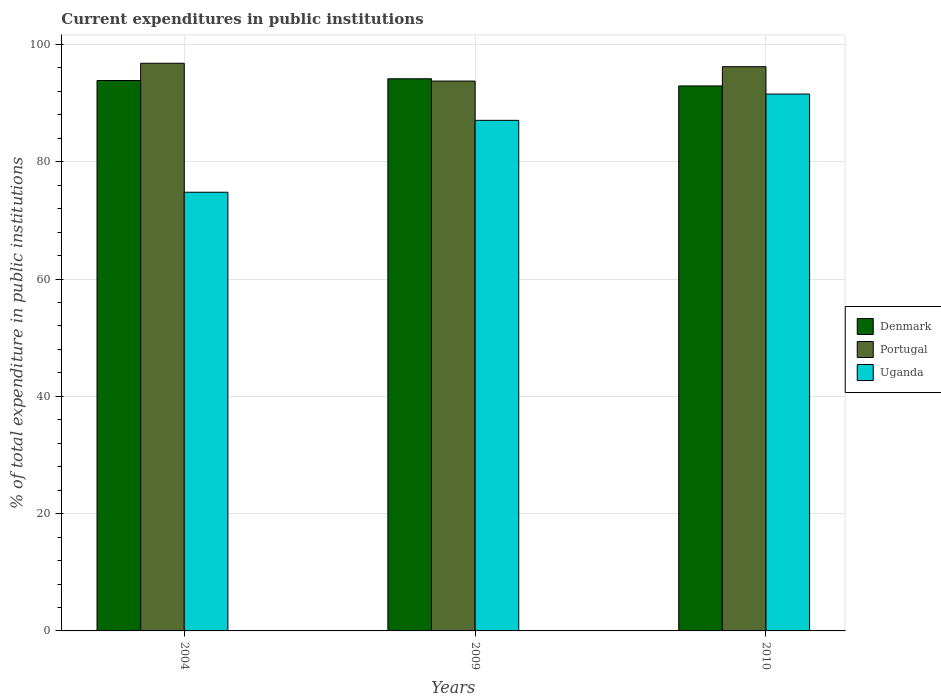How many different coloured bars are there?
Give a very brief answer. 3. How many groups of bars are there?
Your answer should be compact. 3. How many bars are there on the 2nd tick from the right?
Give a very brief answer. 3. What is the current expenditures in public institutions in Portugal in 2004?
Provide a short and direct response. 96.79. Across all years, what is the maximum current expenditures in public institutions in Portugal?
Give a very brief answer. 96.79. Across all years, what is the minimum current expenditures in public institutions in Uganda?
Offer a very short reply. 74.8. In which year was the current expenditures in public institutions in Portugal maximum?
Ensure brevity in your answer.  2004. In which year was the current expenditures in public institutions in Uganda minimum?
Offer a terse response. 2004. What is the total current expenditures in public institutions in Denmark in the graph?
Offer a very short reply. 280.92. What is the difference between the current expenditures in public institutions in Denmark in 2004 and that in 2010?
Make the answer very short. 0.93. What is the difference between the current expenditures in public institutions in Denmark in 2010 and the current expenditures in public institutions in Portugal in 2009?
Your answer should be compact. -0.83. What is the average current expenditures in public institutions in Portugal per year?
Your answer should be compact. 95.59. In the year 2010, what is the difference between the current expenditures in public institutions in Portugal and current expenditures in public institutions in Uganda?
Give a very brief answer. 4.66. What is the ratio of the current expenditures in public institutions in Uganda in 2004 to that in 2010?
Make the answer very short. 0.82. Is the current expenditures in public institutions in Uganda in 2004 less than that in 2009?
Make the answer very short. Yes. Is the difference between the current expenditures in public institutions in Portugal in 2004 and 2009 greater than the difference between the current expenditures in public institutions in Uganda in 2004 and 2009?
Give a very brief answer. Yes. What is the difference between the highest and the second highest current expenditures in public institutions in Uganda?
Make the answer very short. 4.49. What is the difference between the highest and the lowest current expenditures in public institutions in Uganda?
Provide a short and direct response. 16.75. Is the sum of the current expenditures in public institutions in Portugal in 2004 and 2009 greater than the maximum current expenditures in public institutions in Denmark across all years?
Offer a very short reply. Yes. What does the 1st bar from the right in 2009 represents?
Your answer should be compact. Uganda. Is it the case that in every year, the sum of the current expenditures in public institutions in Portugal and current expenditures in public institutions in Uganda is greater than the current expenditures in public institutions in Denmark?
Provide a short and direct response. Yes. Are all the bars in the graph horizontal?
Your answer should be compact. No. How many years are there in the graph?
Provide a short and direct response. 3. What is the difference between two consecutive major ticks on the Y-axis?
Your response must be concise. 20. How many legend labels are there?
Your answer should be very brief. 3. How are the legend labels stacked?
Give a very brief answer. Vertical. What is the title of the graph?
Keep it short and to the point. Current expenditures in public institutions. What is the label or title of the X-axis?
Your answer should be compact. Years. What is the label or title of the Y-axis?
Ensure brevity in your answer.  % of total expenditure in public institutions. What is the % of total expenditure in public institutions of Denmark in 2004?
Provide a short and direct response. 93.85. What is the % of total expenditure in public institutions in Portugal in 2004?
Offer a very short reply. 96.79. What is the % of total expenditure in public institutions in Uganda in 2004?
Your answer should be compact. 74.8. What is the % of total expenditure in public institutions in Denmark in 2009?
Provide a short and direct response. 94.15. What is the % of total expenditure in public institutions of Portugal in 2009?
Offer a very short reply. 93.76. What is the % of total expenditure in public institutions in Uganda in 2009?
Keep it short and to the point. 87.06. What is the % of total expenditure in public institutions in Denmark in 2010?
Keep it short and to the point. 92.93. What is the % of total expenditure in public institutions of Portugal in 2010?
Make the answer very short. 96.21. What is the % of total expenditure in public institutions in Uganda in 2010?
Your answer should be very brief. 91.54. Across all years, what is the maximum % of total expenditure in public institutions of Denmark?
Give a very brief answer. 94.15. Across all years, what is the maximum % of total expenditure in public institutions in Portugal?
Offer a terse response. 96.79. Across all years, what is the maximum % of total expenditure in public institutions of Uganda?
Ensure brevity in your answer.  91.54. Across all years, what is the minimum % of total expenditure in public institutions in Denmark?
Your answer should be very brief. 92.93. Across all years, what is the minimum % of total expenditure in public institutions of Portugal?
Provide a short and direct response. 93.76. Across all years, what is the minimum % of total expenditure in public institutions in Uganda?
Your answer should be compact. 74.8. What is the total % of total expenditure in public institutions of Denmark in the graph?
Your answer should be very brief. 280.92. What is the total % of total expenditure in public institutions of Portugal in the graph?
Make the answer very short. 286.76. What is the total % of total expenditure in public institutions of Uganda in the graph?
Offer a very short reply. 253.4. What is the difference between the % of total expenditure in public institutions of Denmark in 2004 and that in 2009?
Provide a short and direct response. -0.29. What is the difference between the % of total expenditure in public institutions of Portugal in 2004 and that in 2009?
Provide a short and direct response. 3.04. What is the difference between the % of total expenditure in public institutions of Uganda in 2004 and that in 2009?
Your response must be concise. -12.26. What is the difference between the % of total expenditure in public institutions in Denmark in 2004 and that in 2010?
Provide a short and direct response. 0.93. What is the difference between the % of total expenditure in public institutions in Portugal in 2004 and that in 2010?
Offer a terse response. 0.58. What is the difference between the % of total expenditure in public institutions in Uganda in 2004 and that in 2010?
Ensure brevity in your answer.  -16.75. What is the difference between the % of total expenditure in public institutions of Denmark in 2009 and that in 2010?
Offer a very short reply. 1.22. What is the difference between the % of total expenditure in public institutions of Portugal in 2009 and that in 2010?
Your answer should be very brief. -2.45. What is the difference between the % of total expenditure in public institutions in Uganda in 2009 and that in 2010?
Your answer should be very brief. -4.49. What is the difference between the % of total expenditure in public institutions of Denmark in 2004 and the % of total expenditure in public institutions of Portugal in 2009?
Your response must be concise. 0.1. What is the difference between the % of total expenditure in public institutions of Denmark in 2004 and the % of total expenditure in public institutions of Uganda in 2009?
Offer a very short reply. 6.79. What is the difference between the % of total expenditure in public institutions of Portugal in 2004 and the % of total expenditure in public institutions of Uganda in 2009?
Make the answer very short. 9.73. What is the difference between the % of total expenditure in public institutions in Denmark in 2004 and the % of total expenditure in public institutions in Portugal in 2010?
Ensure brevity in your answer.  -2.36. What is the difference between the % of total expenditure in public institutions in Denmark in 2004 and the % of total expenditure in public institutions in Uganda in 2010?
Ensure brevity in your answer.  2.31. What is the difference between the % of total expenditure in public institutions in Portugal in 2004 and the % of total expenditure in public institutions in Uganda in 2010?
Offer a very short reply. 5.25. What is the difference between the % of total expenditure in public institutions of Denmark in 2009 and the % of total expenditure in public institutions of Portugal in 2010?
Offer a very short reply. -2.06. What is the difference between the % of total expenditure in public institutions in Denmark in 2009 and the % of total expenditure in public institutions in Uganda in 2010?
Make the answer very short. 2.6. What is the difference between the % of total expenditure in public institutions of Portugal in 2009 and the % of total expenditure in public institutions of Uganda in 2010?
Provide a short and direct response. 2.21. What is the average % of total expenditure in public institutions of Denmark per year?
Your answer should be compact. 93.64. What is the average % of total expenditure in public institutions in Portugal per year?
Make the answer very short. 95.59. What is the average % of total expenditure in public institutions of Uganda per year?
Your answer should be compact. 84.47. In the year 2004, what is the difference between the % of total expenditure in public institutions in Denmark and % of total expenditure in public institutions in Portugal?
Your response must be concise. -2.94. In the year 2004, what is the difference between the % of total expenditure in public institutions in Denmark and % of total expenditure in public institutions in Uganda?
Offer a very short reply. 19.05. In the year 2004, what is the difference between the % of total expenditure in public institutions of Portugal and % of total expenditure in public institutions of Uganda?
Your response must be concise. 21.99. In the year 2009, what is the difference between the % of total expenditure in public institutions of Denmark and % of total expenditure in public institutions of Portugal?
Keep it short and to the point. 0.39. In the year 2009, what is the difference between the % of total expenditure in public institutions in Denmark and % of total expenditure in public institutions in Uganda?
Keep it short and to the point. 7.09. In the year 2009, what is the difference between the % of total expenditure in public institutions in Portugal and % of total expenditure in public institutions in Uganda?
Your response must be concise. 6.7. In the year 2010, what is the difference between the % of total expenditure in public institutions of Denmark and % of total expenditure in public institutions of Portugal?
Keep it short and to the point. -3.28. In the year 2010, what is the difference between the % of total expenditure in public institutions in Denmark and % of total expenditure in public institutions in Uganda?
Offer a terse response. 1.38. In the year 2010, what is the difference between the % of total expenditure in public institutions in Portugal and % of total expenditure in public institutions in Uganda?
Give a very brief answer. 4.66. What is the ratio of the % of total expenditure in public institutions of Portugal in 2004 to that in 2009?
Your answer should be compact. 1.03. What is the ratio of the % of total expenditure in public institutions in Uganda in 2004 to that in 2009?
Ensure brevity in your answer.  0.86. What is the ratio of the % of total expenditure in public institutions in Denmark in 2004 to that in 2010?
Offer a terse response. 1.01. What is the ratio of the % of total expenditure in public institutions of Portugal in 2004 to that in 2010?
Keep it short and to the point. 1.01. What is the ratio of the % of total expenditure in public institutions in Uganda in 2004 to that in 2010?
Your answer should be compact. 0.82. What is the ratio of the % of total expenditure in public institutions in Denmark in 2009 to that in 2010?
Your response must be concise. 1.01. What is the ratio of the % of total expenditure in public institutions of Portugal in 2009 to that in 2010?
Make the answer very short. 0.97. What is the ratio of the % of total expenditure in public institutions of Uganda in 2009 to that in 2010?
Offer a terse response. 0.95. What is the difference between the highest and the second highest % of total expenditure in public institutions of Denmark?
Make the answer very short. 0.29. What is the difference between the highest and the second highest % of total expenditure in public institutions of Portugal?
Give a very brief answer. 0.58. What is the difference between the highest and the second highest % of total expenditure in public institutions in Uganda?
Your answer should be very brief. 4.49. What is the difference between the highest and the lowest % of total expenditure in public institutions in Denmark?
Offer a very short reply. 1.22. What is the difference between the highest and the lowest % of total expenditure in public institutions in Portugal?
Keep it short and to the point. 3.04. What is the difference between the highest and the lowest % of total expenditure in public institutions of Uganda?
Provide a short and direct response. 16.75. 